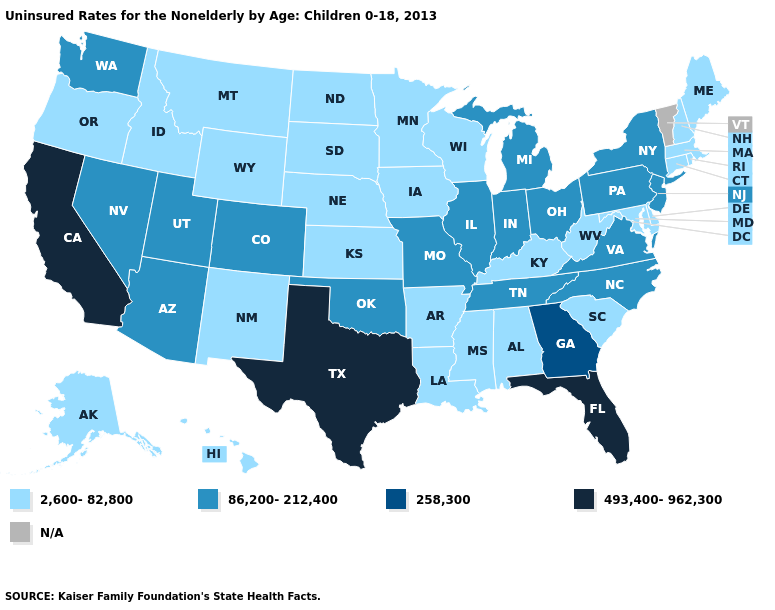Is the legend a continuous bar?
Short answer required. No. Does the first symbol in the legend represent the smallest category?
Answer briefly. Yes. Which states have the lowest value in the MidWest?
Keep it brief. Iowa, Kansas, Minnesota, Nebraska, North Dakota, South Dakota, Wisconsin. How many symbols are there in the legend?
Keep it brief. 5. Does Utah have the lowest value in the West?
Short answer required. No. Among the states that border Rhode Island , which have the highest value?
Answer briefly. Connecticut, Massachusetts. What is the value of Rhode Island?
Keep it brief. 2,600-82,800. What is the highest value in states that border Illinois?
Be succinct. 86,200-212,400. What is the highest value in states that border Idaho?
Give a very brief answer. 86,200-212,400. What is the value of New Hampshire?
Concise answer only. 2,600-82,800. What is the value of Arkansas?
Give a very brief answer. 2,600-82,800. What is the lowest value in the USA?
Write a very short answer. 2,600-82,800. Among the states that border Mississippi , which have the highest value?
Be succinct. Tennessee. What is the highest value in states that border Washington?
Quick response, please. 2,600-82,800. 